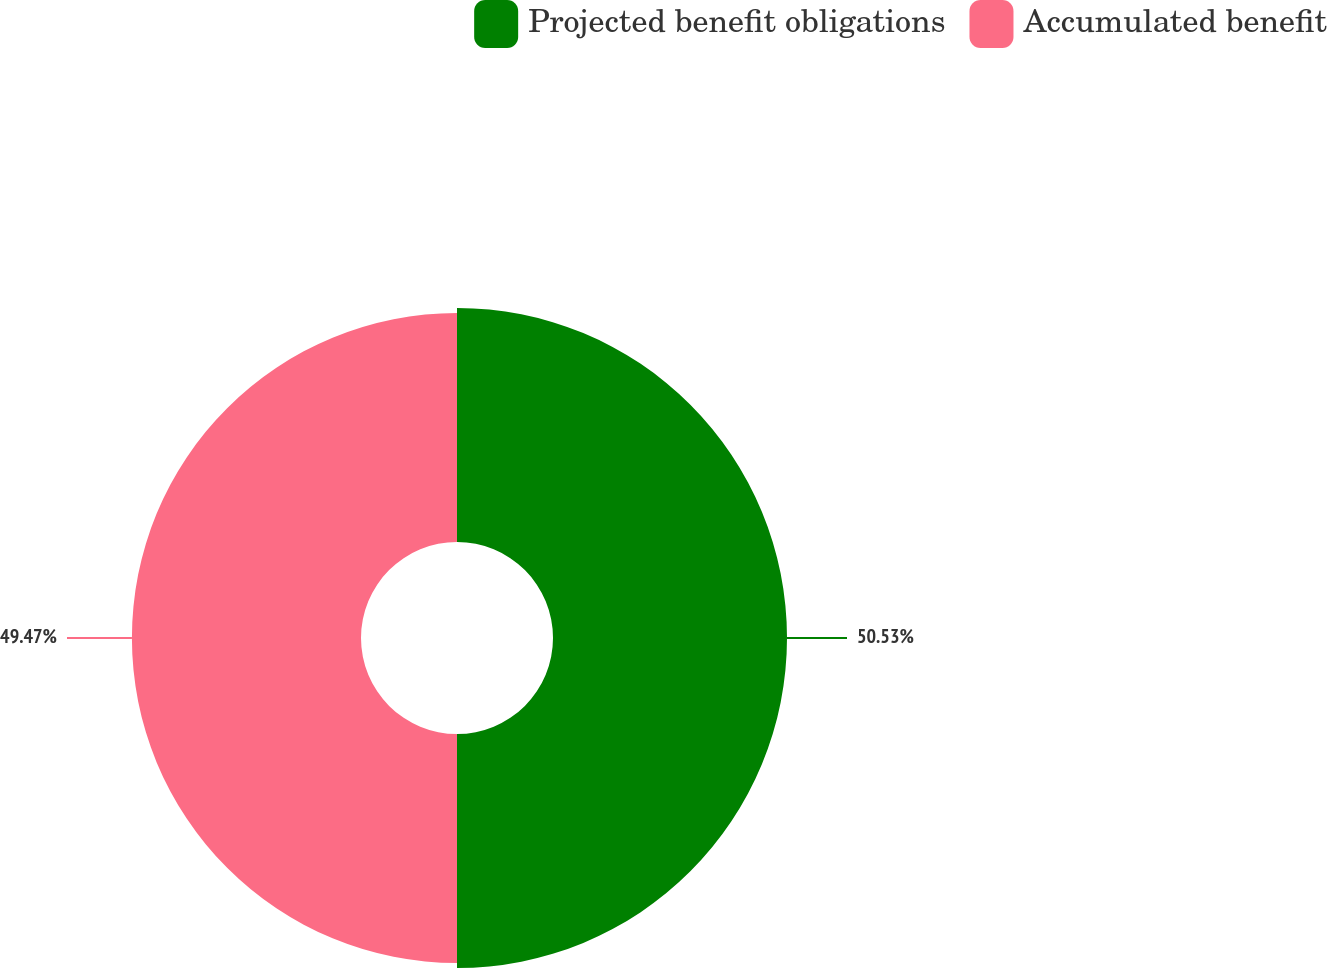Convert chart. <chart><loc_0><loc_0><loc_500><loc_500><pie_chart><fcel>Projected benefit obligations<fcel>Accumulated benefit<nl><fcel>50.53%<fcel>49.47%<nl></chart> 